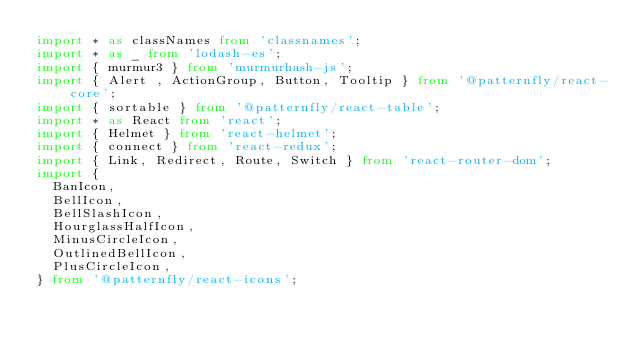<code> <loc_0><loc_0><loc_500><loc_500><_TypeScript_>import * as classNames from 'classnames';
import * as _ from 'lodash-es';
import { murmur3 } from 'murmurhash-js';
import { Alert , ActionGroup, Button, Tooltip } from '@patternfly/react-core';
import { sortable } from '@patternfly/react-table';
import * as React from 'react';
import { Helmet } from 'react-helmet';
import { connect } from 'react-redux';
import { Link, Redirect, Route, Switch } from 'react-router-dom';
import {
  BanIcon,
  BellIcon,
  BellSlashIcon,
  HourglassHalfIcon,
  MinusCircleIcon,
  OutlinedBellIcon,
  PlusCircleIcon,
} from '@patternfly/react-icons';
</code> 